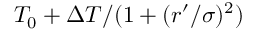Convert formula to latex. <formula><loc_0><loc_0><loc_500><loc_500>T _ { 0 } + \Delta T / ( 1 + ( r ^ { \prime } / \sigma ) ^ { 2 } )</formula> 